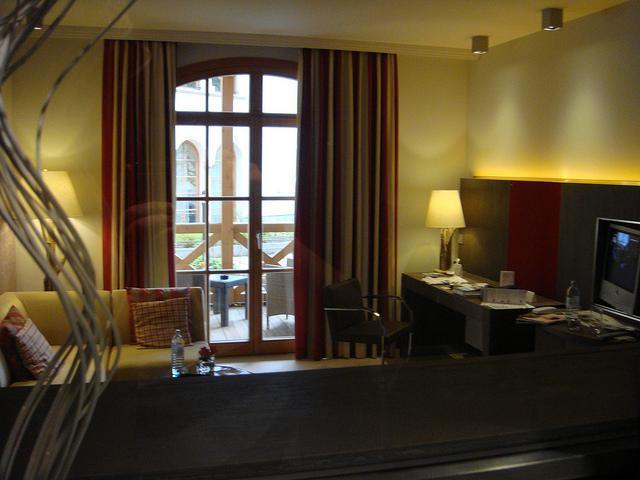How many lamps are on?
Give a very brief answer. 2. 